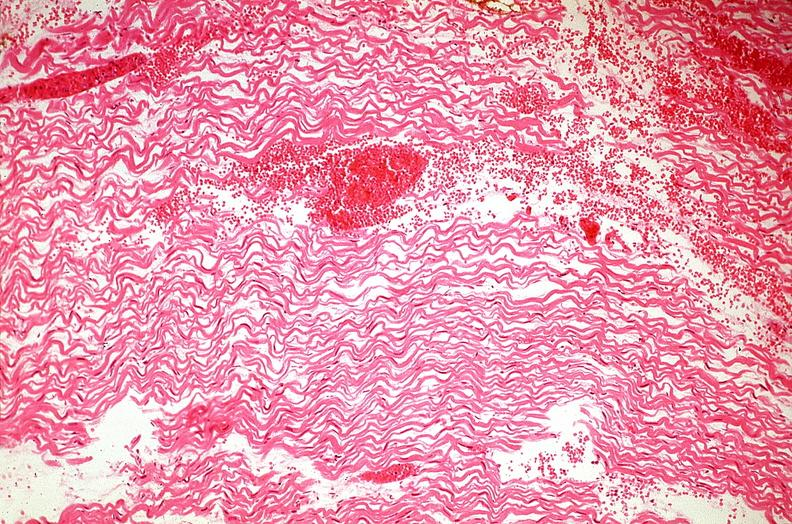does pus in test tube show heart, myocardial infarction, wavey fiber change, necrtosis, hemorrhage, and dissection?
Answer the question using a single word or phrase. No 